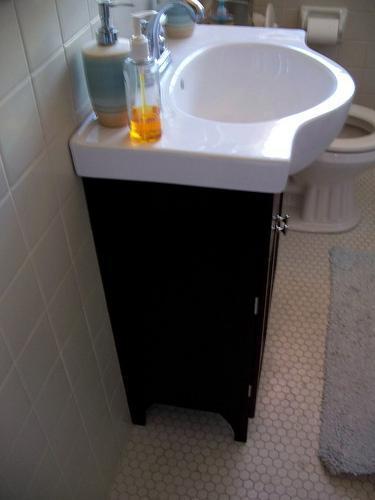How many bottles are there?
Give a very brief answer. 2. 